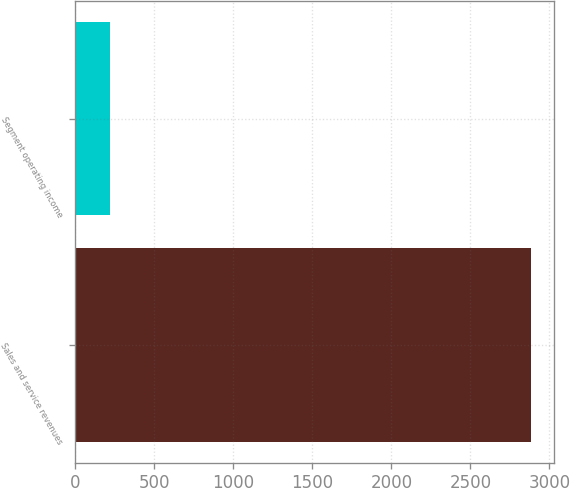<chart> <loc_0><loc_0><loc_500><loc_500><bar_chart><fcel>Sales and service revenues<fcel>Segment operating income<nl><fcel>2885<fcel>220<nl></chart> 